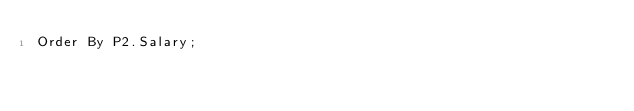Convert code to text. <code><loc_0><loc_0><loc_500><loc_500><_SQL_>Order By P2.Salary;
</code> 